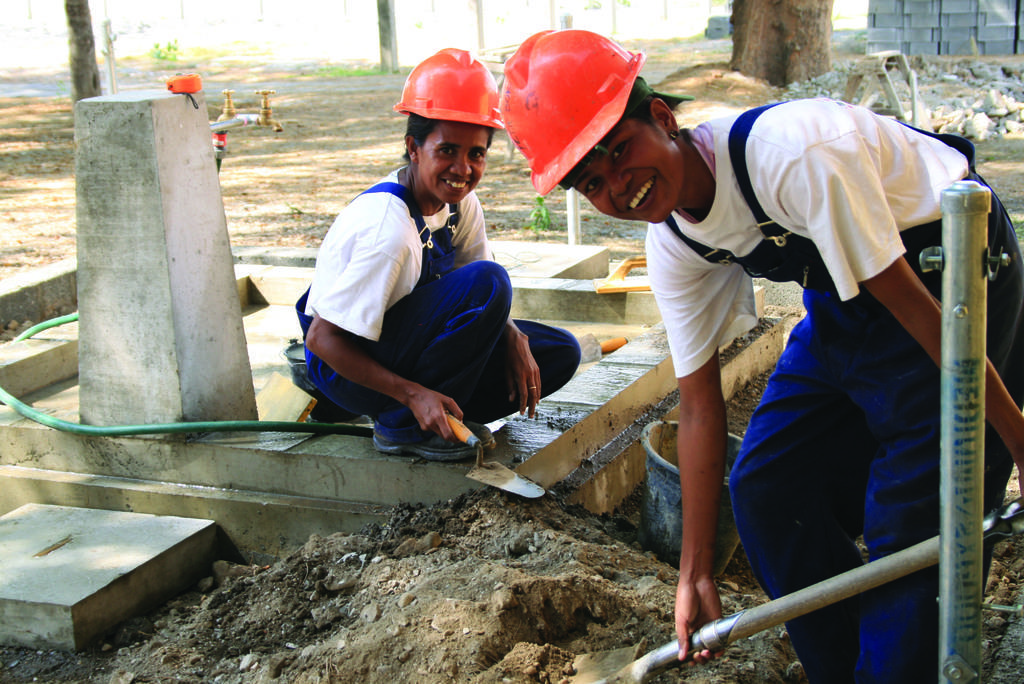Describe this image in one or two sentences. In this picture, we see two women constructing a wall. The woman on the right corner of the picture wearing a white t-shirt and red helmet is digging the soil and both of them are smiling. On the left corner of the picture, we see a tape, measuring tape and green color pipe. Behind them, we see stones and trees. 